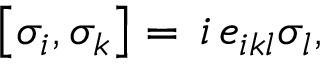Convert formula to latex. <formula><loc_0><loc_0><loc_500><loc_500>\left [ \sigma _ { i } , \sigma _ { k } \right ] = \, i \, e _ { i k l } \sigma _ { l } ,</formula> 